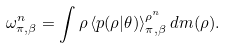<formula> <loc_0><loc_0><loc_500><loc_500>\omega _ { \pi , \beta } ^ { n } = \int \rho \, \langle p ( \rho | \theta ) \rangle _ { \pi , \beta } ^ { \rho ^ { n } } \, d m ( \rho ) .</formula> 